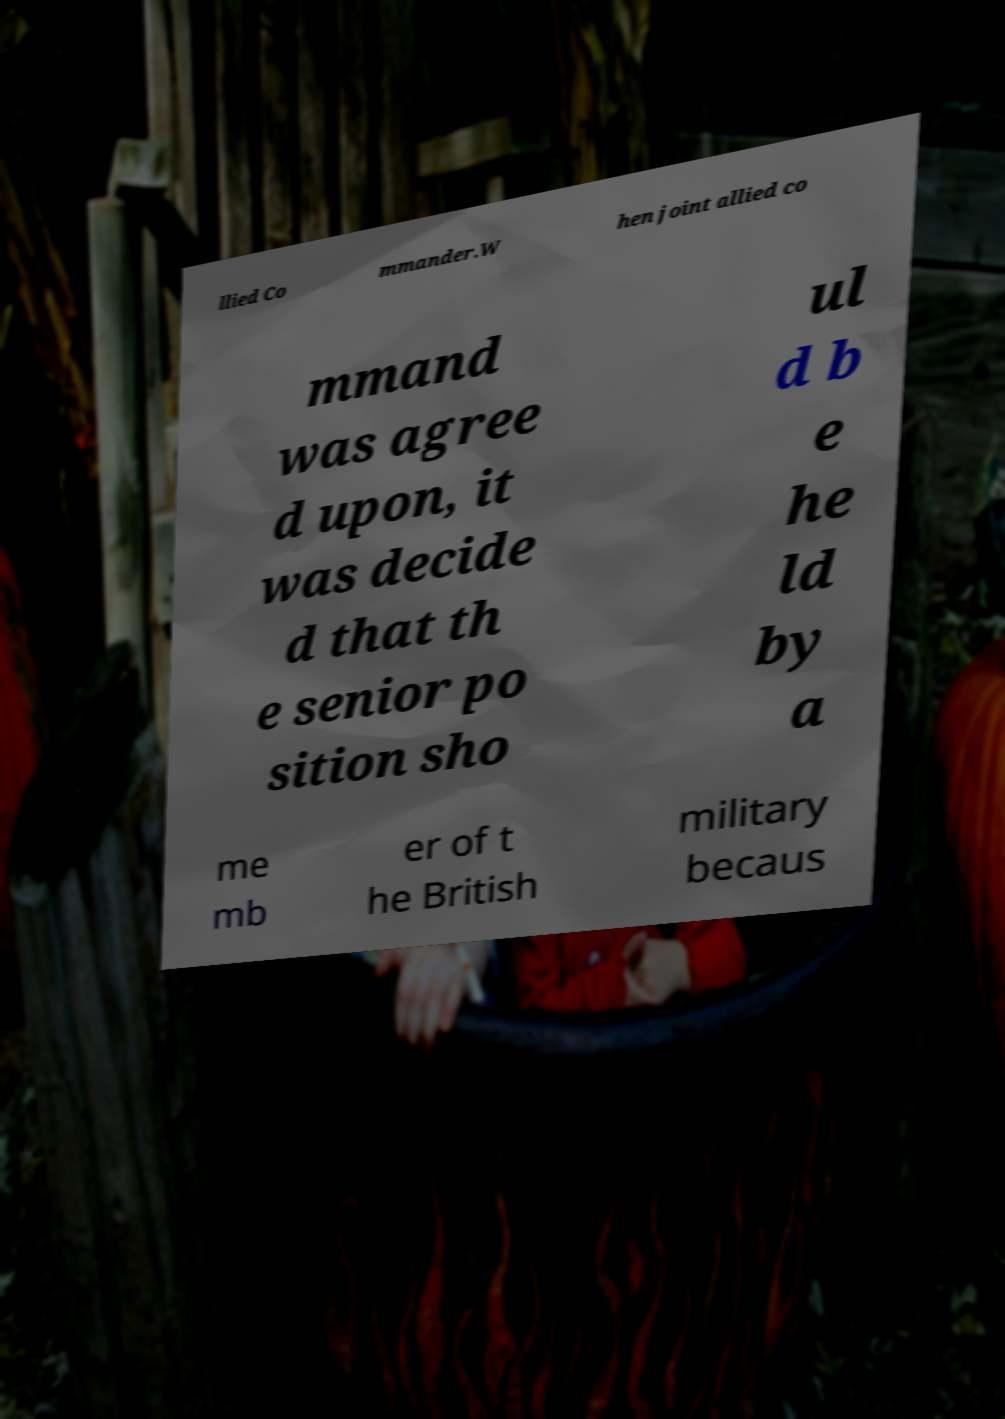Could you assist in decoding the text presented in this image and type it out clearly? llied Co mmander.W hen joint allied co mmand was agree d upon, it was decide d that th e senior po sition sho ul d b e he ld by a me mb er of t he British military becaus 